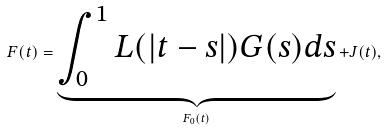Convert formula to latex. <formula><loc_0><loc_0><loc_500><loc_500>F ( t ) = \underbrace { \int ^ { 1 } _ { 0 } L ( | t - s | ) G ( s ) d s } _ { F _ { 0 } ( t ) } + J ( t ) ,</formula> 